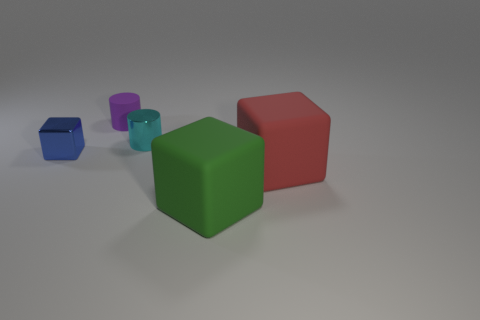Add 2 large blue metallic cylinders. How many objects exist? 7 Subtract all cylinders. How many objects are left? 3 Subtract all big green things. Subtract all blocks. How many objects are left? 1 Add 1 tiny metallic cylinders. How many tiny metallic cylinders are left? 2 Add 2 small cubes. How many small cubes exist? 3 Subtract 1 purple cylinders. How many objects are left? 4 